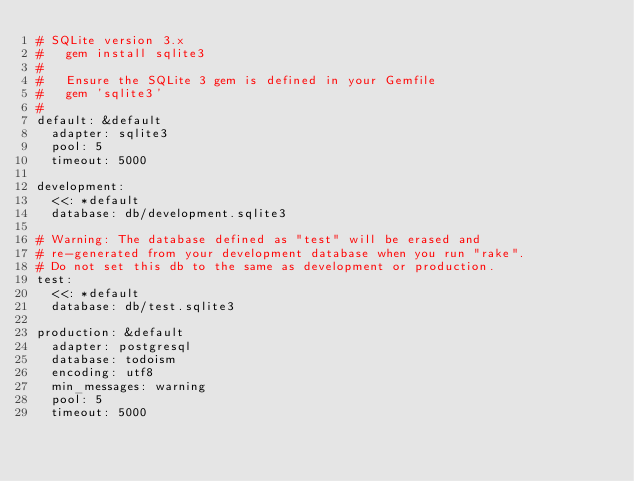Convert code to text. <code><loc_0><loc_0><loc_500><loc_500><_YAML_># SQLite version 3.x
#   gem install sqlite3
#
#   Ensure the SQLite 3 gem is defined in your Gemfile
#   gem 'sqlite3'
#
default: &default
  adapter: sqlite3
  pool: 5
  timeout: 5000

development:
  <<: *default
  database: db/development.sqlite3

# Warning: The database defined as "test" will be erased and
# re-generated from your development database when you run "rake".
# Do not set this db to the same as development or production.
test:
  <<: *default
  database: db/test.sqlite3

production: &default
  adapter: postgresql
  database: todoism
  encoding: utf8
  min_messages: warning
  pool: 5
  timeout: 5000
</code> 